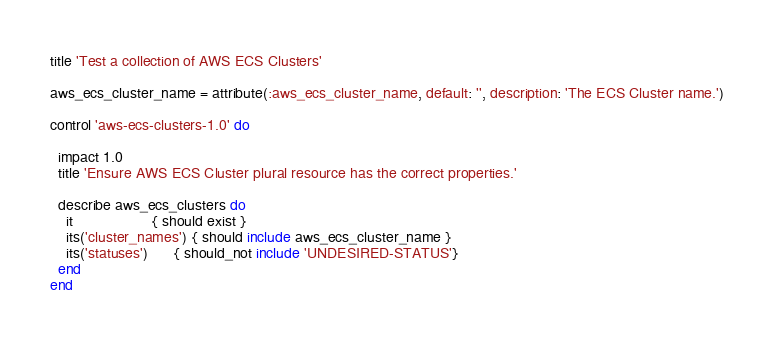<code> <loc_0><loc_0><loc_500><loc_500><_Ruby_>title 'Test a collection of AWS ECS Clusters'

aws_ecs_cluster_name = attribute(:aws_ecs_cluster_name, default: '', description: 'The ECS Cluster name.')

control 'aws-ecs-clusters-1.0' do

  impact 1.0
  title 'Ensure AWS ECS Cluster plural resource has the correct properties.'

  describe aws_ecs_clusters do
    it                   { should exist }
    its('cluster_names') { should include aws_ecs_cluster_name }
    its('statuses')      { should_not include 'UNDESIRED-STATUS'}
  end
end</code> 